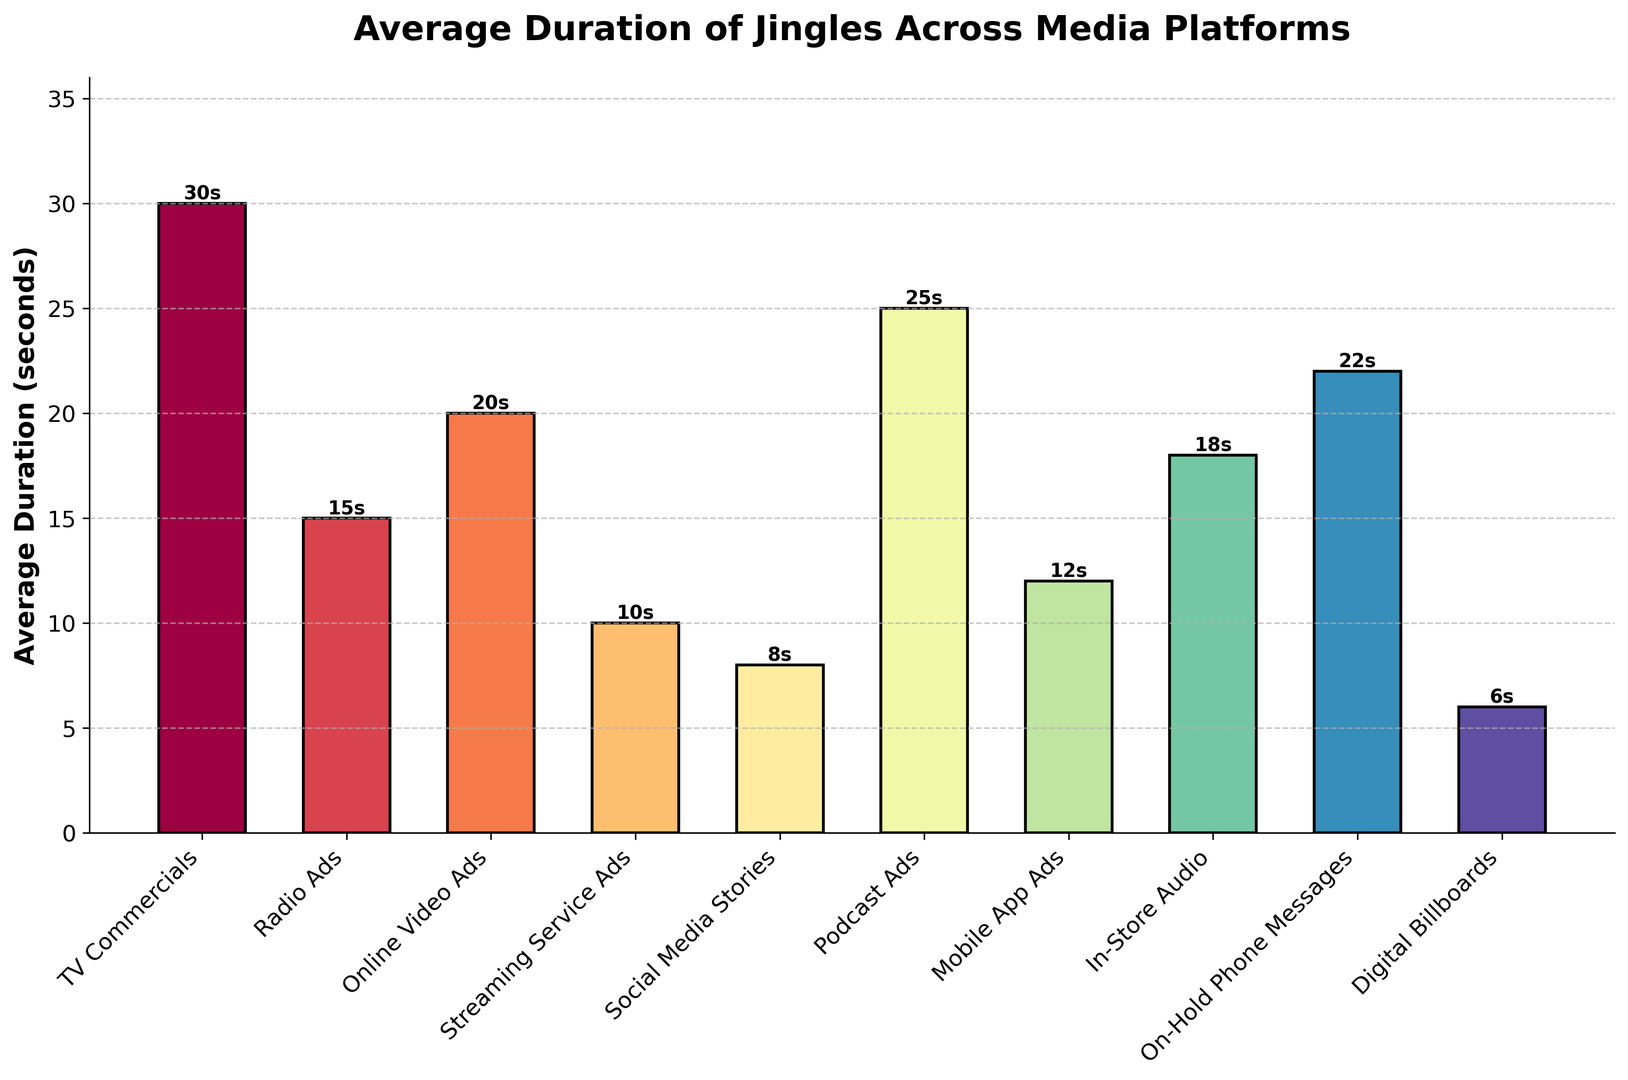What platform has the longest average duration for jingles? The bar representing "TV Commercials" is the tallest, implying the longest duration.
Answer: TV Commercials Which media platform has the shortest average jingle duration? The shortest bar corresponds to "Digital Billboards".
Answer: Digital Billboards How much longer are jingles on podcasts compared to those on streaming services? The height of "Podcast Ads" bar is 25 seconds and "Streaming Service Ads" is 10 seconds. The difference is 25 - 10.
Answer: 15 seconds Are the average durations of jingles in TV Commercials and On-Hold Phone Messages the same? If not, which one is longer and by how much? The "TV Commercials" bar reaches up to 30 seconds and "On-Hold Phone Messages" reaches 22 seconds. TV Commercials are longer and the difference is 30 - 22.
Answer: No, TV Commercials by 8 seconds What is the combined duration of jingles for Social Media Stories, Streaming Service Ads, and Digital Billboards? Add the heights of the bars for "Social Media Stories" (8 seconds), "Streaming Service Ads" (10 seconds), and "Digital Billboards" (6 seconds). 8 + 10 + 6 = 24.
Answer: 24 seconds Which platform(s) have an average jingle duration between 15 and 25 seconds? Look for bars whose height falls between 15 and 25 seconds, corresponding to "Radio Ads" (15), "Podcast Ads" (25), "In-Store Audio" (18), "On-Hold Phone Messages" (22).
Answer: Radio Ads, Podcast Ads, In-Store Audio, On-Hold Phone Messages What is the median duration of the jingle data presented? Order the average durations: 6, 8, 10, 12, 15, 18, 20, 22, 25, 30. The middle values are 15 and 18, so the median is (15 + 18) / 2.
Answer: 16.5 seconds Compare the total duration of jingles for radio and online (Radio Ads, Online Video Ads, Podcast Ads) versus mobile and in-store advertising (Mobile App Ads, In-Store Audio, On-Hold Phone Messages). Which group has a higher total duration? Sum for radio and online (15 + 20 + 25 = 60). Sum for mobile and in-store (12 + 18 + 22 = 52). Compare sums.
Answer: Radio and online have a higher total (60 vs 52) Estimate the average duration of all jingles across the listed platforms. Add all durations (30, 15, 20, 10, 8, 25, 12, 18, 22, 6) and divide by the number of platforms (10). The total is 166, so the average is 166 / 10.
Answer: 16.6 seconds Is the duration for Mobile App Ads closer to Streaming Service Ads or In-Store Audio? Compare differences: Mobile App Ads (12) - Streaming Service Ads (10) = 2; In-Store Audio (18) - Mobile App Ads (12) = 6. Mobile App Ads are closer to Streaming Service Ads.
Answer: Streaming Service Ads 